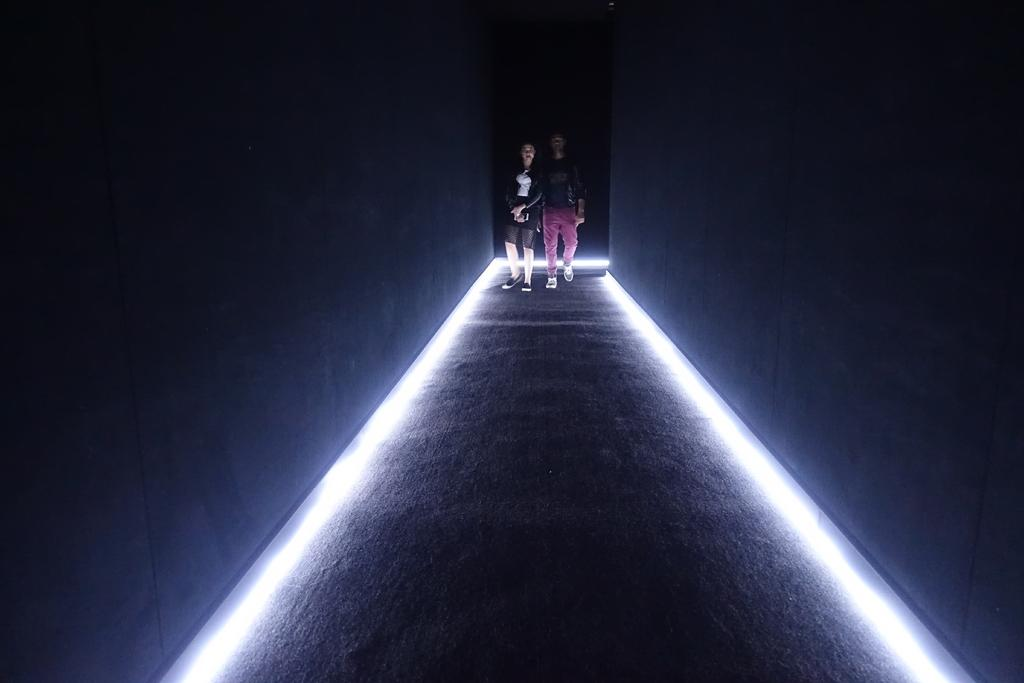How many people are present in the image? There are two people standing in the image. What can be seen in the background or surroundings of the people? There are lights and walls visible in the image. Can you describe the lighting conditions in the image? The image appears to be slightly dark. What type of crown is being worn by the person on the left in the image? There is no crown present in the image; it only shows two people standing. 